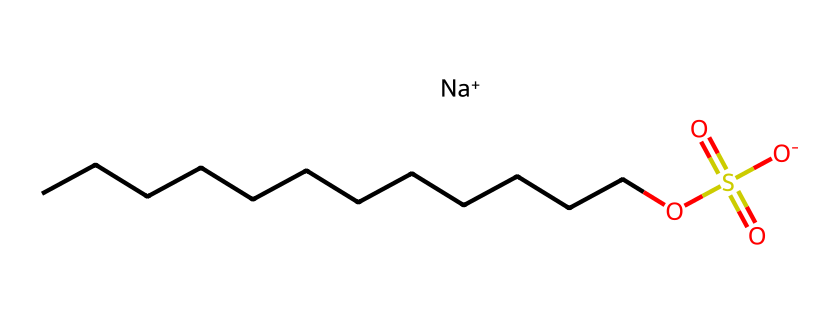What is the molecular formula of sodium lauryl sulfate? The SMILES representation shows that the compound consists of several carbon atoms (C), a sulfur atom (S), and oxygen atoms (O). Counting the elements reveals the formula is C12H25NaO4S.
Answer: C12H25NaO4S How many carbon atoms are in sodium lauryl sulfate? From the chemical structure indicated by the SMILES, there are 12 carbon atoms represented by the "CCCCCCCCCCCC" part.
Answer: 12 What is the charge of the sodium ion in sodium lauryl sulfate? The SMILES notation represents "Na+" which indicates that the sodium ion has a positive charge.
Answer: positive Which functional group is indicated by the "OS(=O)(=O)" in the structure? The "OS(=O)(=O)" portion indicates a sulfonate group, which is characteristic of surfactants. It implies the presence of sulfur and two double-bonded oxygen atoms, leading to a negatively charged sulfate group.
Answer: sulfonate What role does sodium lauryl sulfate play in hand soap? Sodium lauryl sulfate acts as a surfactant in hand soap, which facilitates the removal of dirt and oils by reducing the surface tension of water. This is indicated by its amphiphilic structure, featuring both a hydrophobic tail (the long carbon chain) and a hydrophilic head (the sulfonate group).
Answer: surfactant Why is sodium lauryl sulfate effective at cleaning? The effectiveness of sodium lauryl sulfate in cleaning is due to its dual nature, having a long hydrophobic carbon chain that binds to oils and a hydrophilic sulfate group that interacts with water. This structural characteristic allows it to emulsify oils and dirt in water, enabling their removal.
Answer: dual nature 